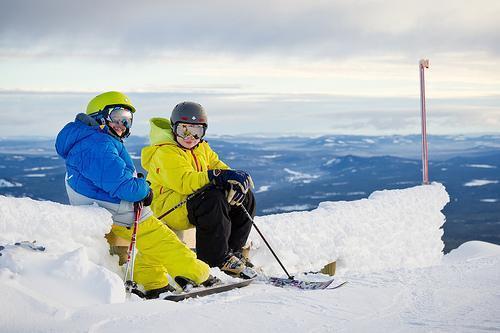How many people are in the photo?
Give a very brief answer. 2. 